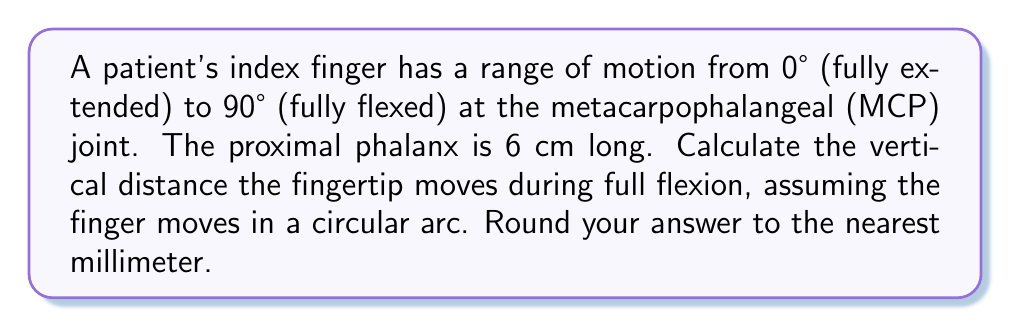Can you answer this question? Let's approach this step-by-step:

1) The finger's motion describes a circular arc, with the MCP joint as the center and the proximal phalanx as the radius.

2) We need to find the difference between the vertical positions of the fingertip when fully extended (0°) and fully flexed (90°).

3) When fully extended (0°), the fingertip is at the same level as the MCP joint. Let's call this position y₀.

4) When fully flexed (90°), the fingertip is directly below the MCP joint. Let's call this position y₁.

5) The vertical distance moved is |y₁ - y₀|.

6) We can use the sine function to calculate y₁:

   $$y_1 = r \sin(90°) = 6 \sin(90°) = 6 \cdot 1 = 6\text{ cm}$$

7) y₀ is 0 cm (same level as MCP joint).

8) Therefore, the vertical distance moved is:

   $$|y_1 - y_0| = |6 - 0| = 6\text{ cm}$$

9) Converting to millimeters:

   $$6\text{ cm} = 60\text{ mm}$$

Thus, the fingertip moves 60 mm vertically during full flexion.
Answer: 60 mm 